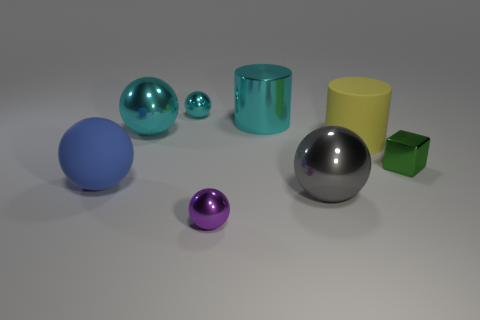The small ball in front of the large rubber thing on the right side of the small metallic sphere behind the big blue object is what color?
Offer a terse response. Purple. The sphere that is the same size as the purple thing is what color?
Your answer should be very brief. Cyan. How many metallic things are either big yellow cylinders or large cylinders?
Ensure brevity in your answer.  1. The other object that is the same material as the yellow object is what color?
Your answer should be compact. Blue. The tiny sphere that is behind the matte thing behind the blue matte object is made of what material?
Your answer should be compact. Metal. What number of things are either things that are in front of the tiny green metallic thing or things that are behind the green thing?
Your answer should be very brief. 7. How big is the cyan object to the left of the small sphere behind the tiny metal object that is in front of the tiny green thing?
Offer a very short reply. Large. Is the number of purple metallic balls that are behind the tiny cube the same as the number of big cyan spheres?
Your answer should be compact. No. Is there any other thing that is the same shape as the big gray shiny thing?
Offer a terse response. Yes. There is a gray thing; is its shape the same as the cyan metal thing behind the cyan metal cylinder?
Provide a short and direct response. Yes. 